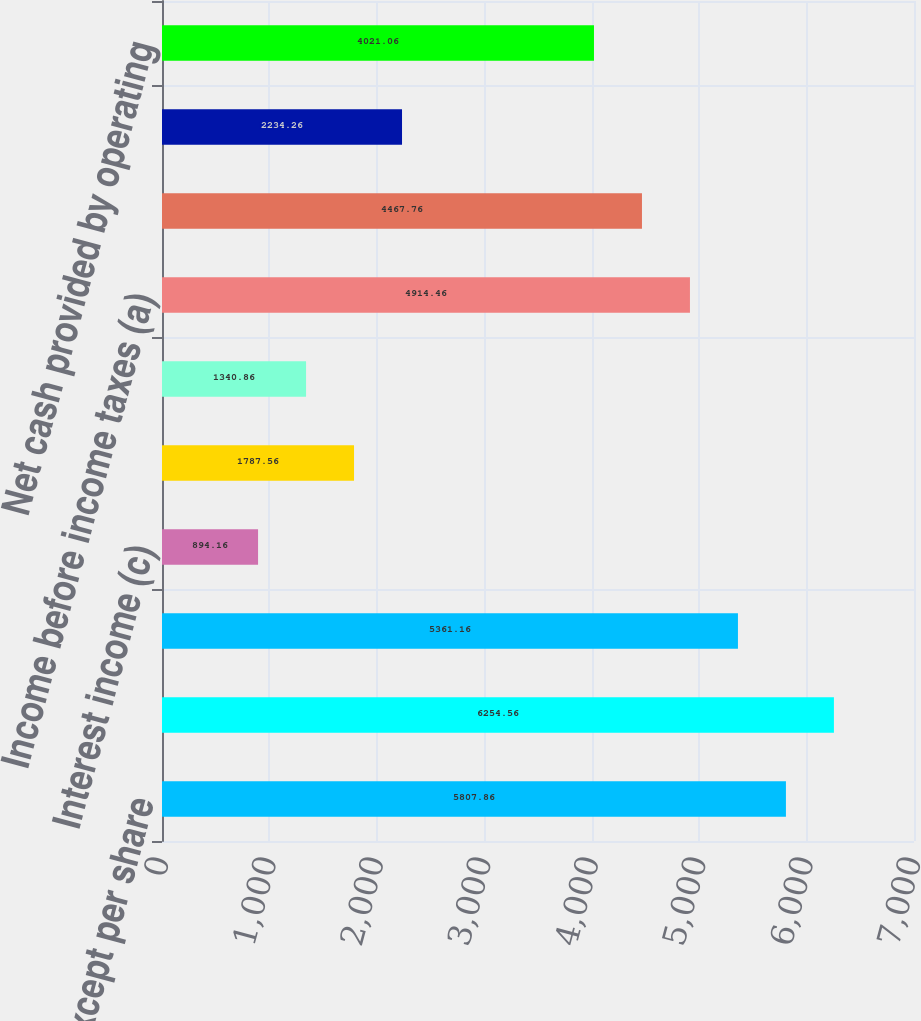Convert chart. <chart><loc_0><loc_0><loc_500><loc_500><bar_chart><fcel>(in millions except per share<fcel>Operating expenses(a) (b)<fcel>Operating income (a)(b)<fcel>Interest income (c)<fcel>Interest expense (d)<fcel>Other income/(expense)net(b)<fcel>Income before income taxes (a)<fcel>Net income/(loss)(a)(c) (d)<fcel>Depreciation and amortization<fcel>Net cash provided by operating<nl><fcel>5807.86<fcel>6254.56<fcel>5361.16<fcel>894.16<fcel>1787.56<fcel>1340.86<fcel>4914.46<fcel>4467.76<fcel>2234.26<fcel>4021.06<nl></chart> 